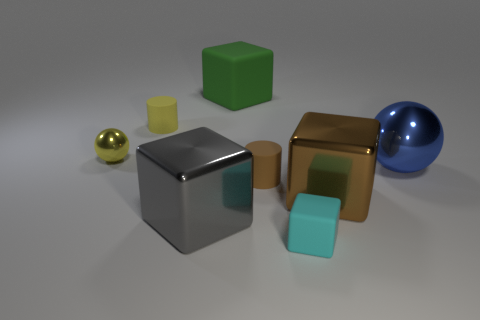There is a tiny thing that is the same color as the small metal sphere; what is its shape?
Keep it short and to the point. Cylinder. What number of things are large green matte blocks or large metallic objects in front of the blue shiny thing?
Your answer should be very brief. 3. Are there any metal objects that have the same shape as the large green rubber object?
Your answer should be compact. Yes. Are there the same number of small brown rubber objects on the right side of the yellow matte cylinder and brown shiny objects that are to the left of the big brown metallic object?
Provide a succinct answer. No. What number of green objects are either metallic objects or large matte blocks?
Ensure brevity in your answer.  1. What number of cubes are the same size as the gray object?
Ensure brevity in your answer.  2. The large object that is left of the big blue thing and right of the small block is what color?
Provide a succinct answer. Brown. Is the number of small cyan blocks in front of the blue sphere greater than the number of large cyan rubber blocks?
Ensure brevity in your answer.  Yes. Are there any tiny yellow cylinders?
Provide a succinct answer. Yes. How many tiny things are brown objects or spheres?
Make the answer very short. 2. 